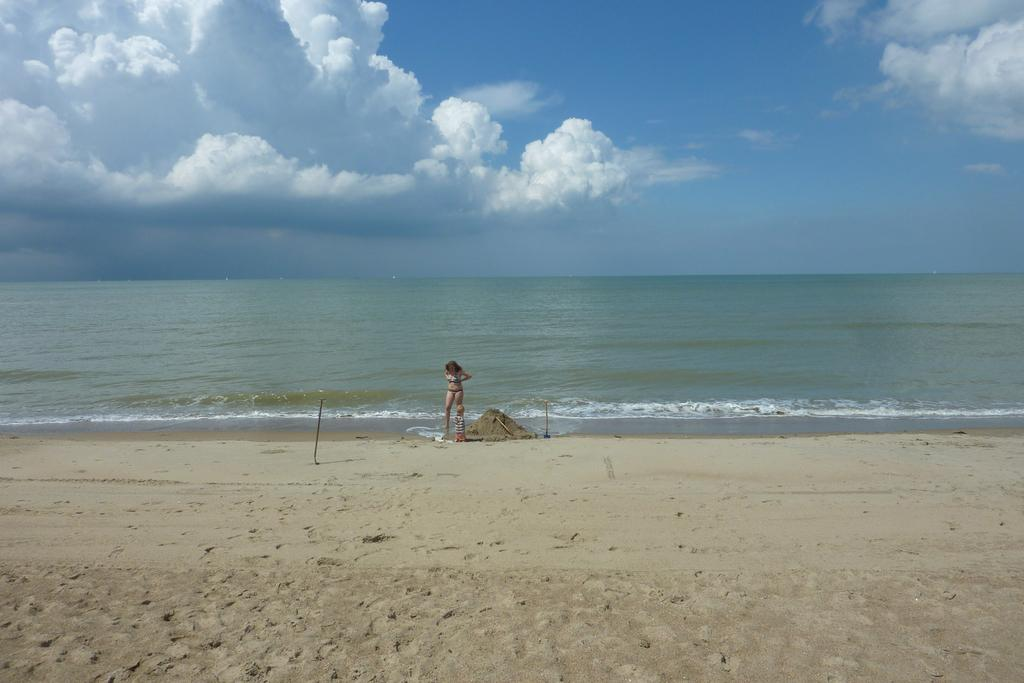Who is the main subject in the image? There is a lady standing in the center of the image. What can be seen in the background of the image? There is water visible in the background. What type of terrain is at the bottom of the image? There is sand at the bottom of the image. What else is visible in the background of the image? The sky is visible in the background. What type of rabbit can be seen swimming in the ocean in the image? There is no rabbit or ocean present in the image; it features a lady standing on sand with water and sky visible in the background. 